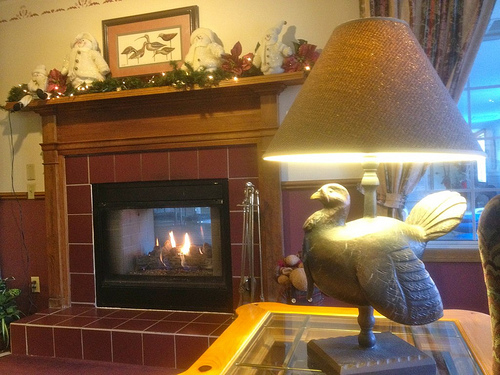<image>
Is there a bird under the lampshade? Yes. The bird is positioned underneath the lampshade, with the lampshade above it in the vertical space. Is the bird under the lamp? Yes. The bird is positioned underneath the lamp, with the lamp above it in the vertical space. Is the fire behind the iron? Yes. From this viewpoint, the fire is positioned behind the iron, with the iron partially or fully occluding the fire. 